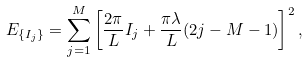Convert formula to latex. <formula><loc_0><loc_0><loc_500><loc_500>E _ { \{ I _ { j } \} } = \sum _ { j = 1 } ^ { M } \left [ \frac { 2 \pi } { L } I _ { j } + \frac { \pi \lambda } { L } ( 2 j - M - 1 ) \right ] ^ { 2 } ,</formula> 